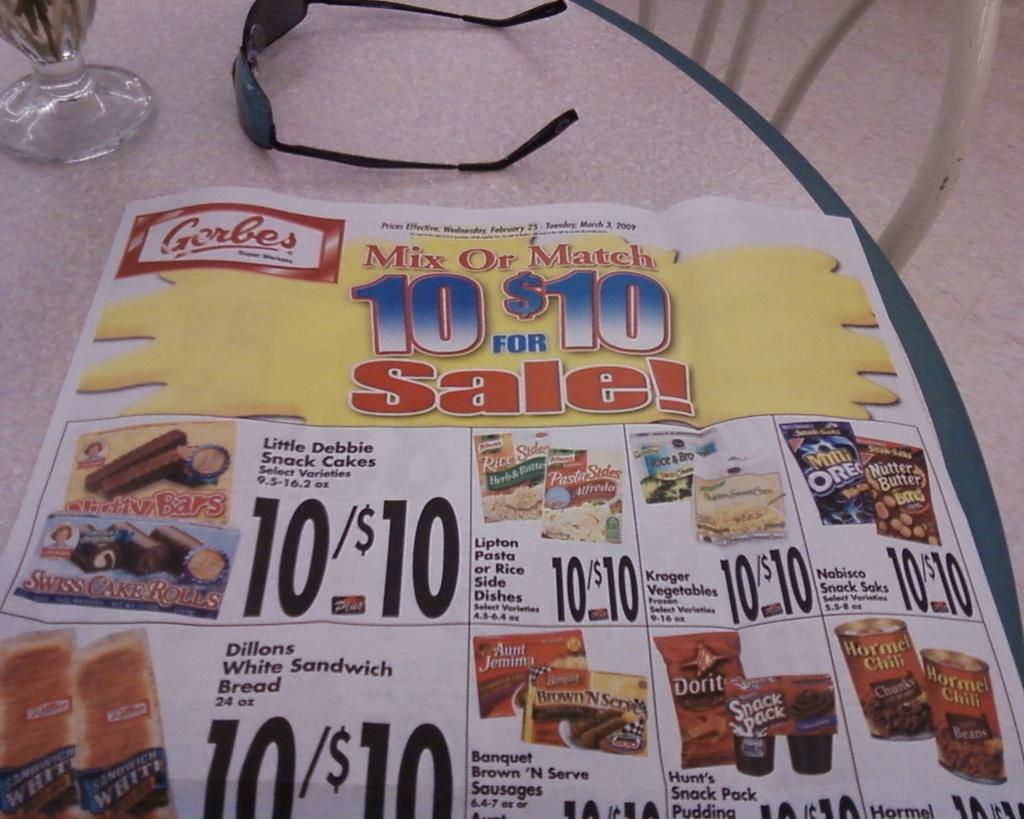What objects are made of glass in the image? There are glasses in the image. What type of material is the paper made of in the image? The paper in the image is made of paper. What object is used for drinking in the image? There is a glass in the image that can be used for drinking. What type of furniture is present in the image? There is a chair in the image. What surface can be seen at the bottom of the image? The floor is visible in the image. What type of finger food is being served for breakfast in the image? There is no finger food or breakfast depicted in the image; it only contains glasses, paper, a glass, a chair, and the floor. 